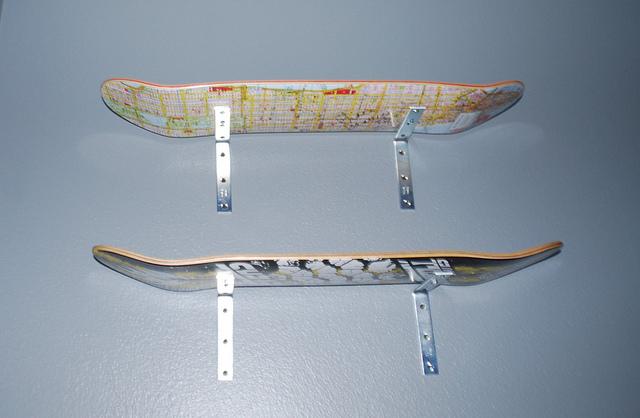What is the color of the wall?
Answer briefly. Blue. What are these skateboards missing?
Answer briefly. Wheels. Are these shelves?
Write a very short answer. Yes. 